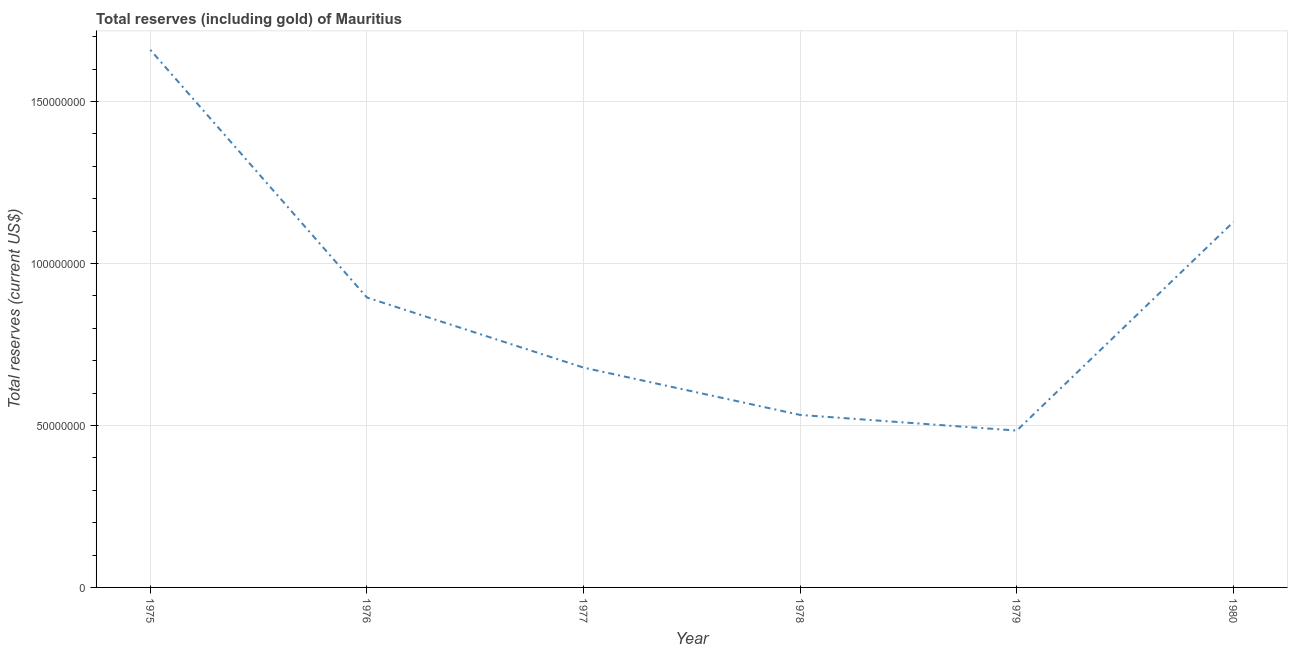What is the total reserves (including gold) in 1979?
Provide a succinct answer. 4.84e+07. Across all years, what is the maximum total reserves (including gold)?
Your response must be concise. 1.66e+08. Across all years, what is the minimum total reserves (including gold)?
Offer a very short reply. 4.84e+07. In which year was the total reserves (including gold) maximum?
Provide a succinct answer. 1975. In which year was the total reserves (including gold) minimum?
Make the answer very short. 1979. What is the sum of the total reserves (including gold)?
Provide a short and direct response. 5.38e+08. What is the difference between the total reserves (including gold) in 1979 and 1980?
Give a very brief answer. -6.44e+07. What is the average total reserves (including gold) per year?
Offer a terse response. 8.96e+07. What is the median total reserves (including gold)?
Ensure brevity in your answer.  7.87e+07. In how many years, is the total reserves (including gold) greater than 30000000 US$?
Provide a succinct answer. 6. Do a majority of the years between 1975 and 1979 (inclusive) have total reserves (including gold) greater than 60000000 US$?
Offer a very short reply. Yes. What is the ratio of the total reserves (including gold) in 1977 to that in 1978?
Ensure brevity in your answer.  1.27. What is the difference between the highest and the second highest total reserves (including gold)?
Your answer should be very brief. 5.32e+07. Is the sum of the total reserves (including gold) in 1975 and 1979 greater than the maximum total reserves (including gold) across all years?
Your answer should be compact. Yes. What is the difference between the highest and the lowest total reserves (including gold)?
Offer a terse response. 1.18e+08. In how many years, is the total reserves (including gold) greater than the average total reserves (including gold) taken over all years?
Offer a very short reply. 2. Does the total reserves (including gold) monotonically increase over the years?
Your answer should be very brief. No. Are the values on the major ticks of Y-axis written in scientific E-notation?
Your answer should be very brief. No. Does the graph contain grids?
Provide a short and direct response. Yes. What is the title of the graph?
Offer a terse response. Total reserves (including gold) of Mauritius. What is the label or title of the X-axis?
Provide a succinct answer. Year. What is the label or title of the Y-axis?
Your response must be concise. Total reserves (current US$). What is the Total reserves (current US$) of 1975?
Give a very brief answer. 1.66e+08. What is the Total reserves (current US$) in 1976?
Give a very brief answer. 8.95e+07. What is the Total reserves (current US$) of 1977?
Offer a terse response. 6.79e+07. What is the Total reserves (current US$) in 1978?
Give a very brief answer. 5.33e+07. What is the Total reserves (current US$) of 1979?
Keep it short and to the point. 4.84e+07. What is the Total reserves (current US$) in 1980?
Your response must be concise. 1.13e+08. What is the difference between the Total reserves (current US$) in 1975 and 1976?
Give a very brief answer. 7.65e+07. What is the difference between the Total reserves (current US$) in 1975 and 1977?
Give a very brief answer. 9.81e+07. What is the difference between the Total reserves (current US$) in 1975 and 1978?
Offer a terse response. 1.13e+08. What is the difference between the Total reserves (current US$) in 1975 and 1979?
Give a very brief answer. 1.18e+08. What is the difference between the Total reserves (current US$) in 1975 and 1980?
Your answer should be compact. 5.32e+07. What is the difference between the Total reserves (current US$) in 1976 and 1977?
Ensure brevity in your answer.  2.16e+07. What is the difference between the Total reserves (current US$) in 1976 and 1978?
Offer a terse response. 3.63e+07. What is the difference between the Total reserves (current US$) in 1976 and 1979?
Provide a short and direct response. 4.11e+07. What is the difference between the Total reserves (current US$) in 1976 and 1980?
Offer a terse response. -2.33e+07. What is the difference between the Total reserves (current US$) in 1977 and 1978?
Give a very brief answer. 1.46e+07. What is the difference between the Total reserves (current US$) in 1977 and 1979?
Ensure brevity in your answer.  1.94e+07. What is the difference between the Total reserves (current US$) in 1977 and 1980?
Provide a short and direct response. -4.50e+07. What is the difference between the Total reserves (current US$) in 1978 and 1979?
Make the answer very short. 4.83e+06. What is the difference between the Total reserves (current US$) in 1978 and 1980?
Make the answer very short. -5.96e+07. What is the difference between the Total reserves (current US$) in 1979 and 1980?
Ensure brevity in your answer.  -6.44e+07. What is the ratio of the Total reserves (current US$) in 1975 to that in 1976?
Make the answer very short. 1.85. What is the ratio of the Total reserves (current US$) in 1975 to that in 1977?
Give a very brief answer. 2.44. What is the ratio of the Total reserves (current US$) in 1975 to that in 1978?
Give a very brief answer. 3.12. What is the ratio of the Total reserves (current US$) in 1975 to that in 1979?
Provide a short and direct response. 3.43. What is the ratio of the Total reserves (current US$) in 1975 to that in 1980?
Offer a terse response. 1.47. What is the ratio of the Total reserves (current US$) in 1976 to that in 1977?
Make the answer very short. 1.32. What is the ratio of the Total reserves (current US$) in 1976 to that in 1978?
Offer a terse response. 1.68. What is the ratio of the Total reserves (current US$) in 1976 to that in 1979?
Offer a terse response. 1.85. What is the ratio of the Total reserves (current US$) in 1976 to that in 1980?
Provide a short and direct response. 0.79. What is the ratio of the Total reserves (current US$) in 1977 to that in 1978?
Keep it short and to the point. 1.27. What is the ratio of the Total reserves (current US$) in 1977 to that in 1979?
Your answer should be very brief. 1.4. What is the ratio of the Total reserves (current US$) in 1977 to that in 1980?
Your answer should be very brief. 0.6. What is the ratio of the Total reserves (current US$) in 1978 to that in 1979?
Offer a very short reply. 1.1. What is the ratio of the Total reserves (current US$) in 1978 to that in 1980?
Provide a succinct answer. 0.47. What is the ratio of the Total reserves (current US$) in 1979 to that in 1980?
Provide a succinct answer. 0.43. 